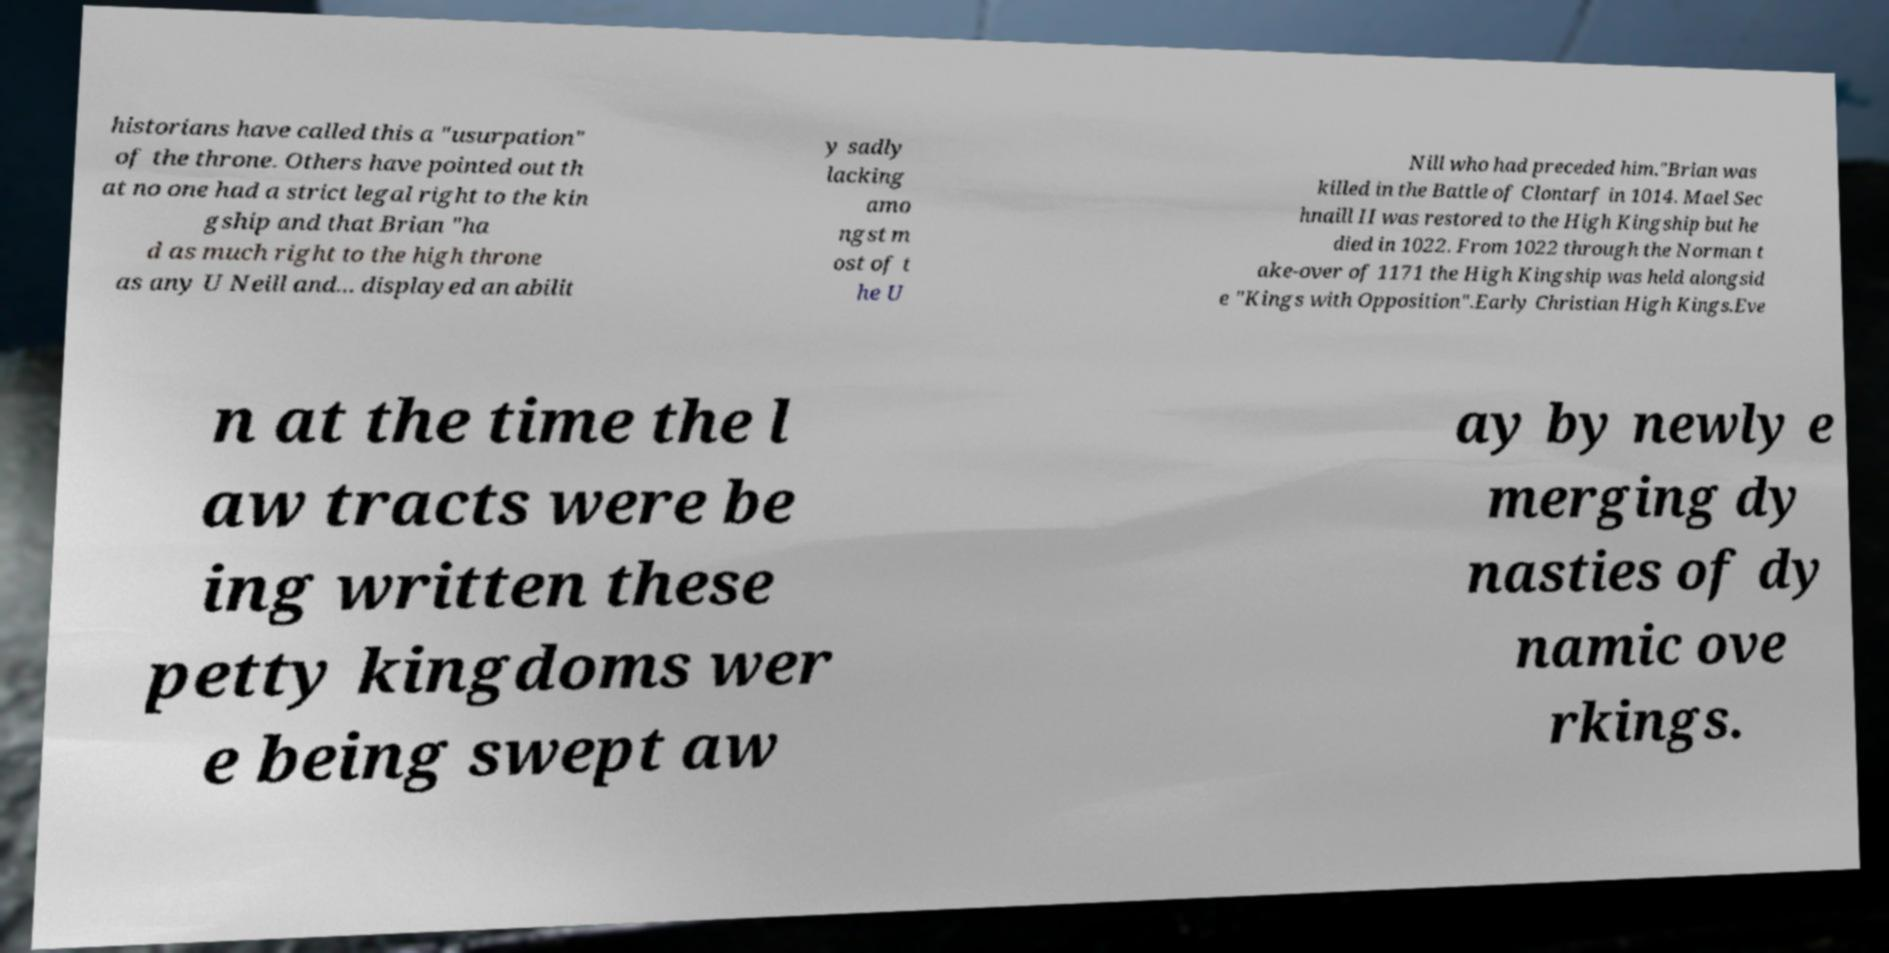Can you accurately transcribe the text from the provided image for me? historians have called this a "usurpation" of the throne. Others have pointed out th at no one had a strict legal right to the kin gship and that Brian "ha d as much right to the high throne as any U Neill and... displayed an abilit y sadly lacking amo ngst m ost of t he U Nill who had preceded him."Brian was killed in the Battle of Clontarf in 1014. Mael Sec hnaill II was restored to the High Kingship but he died in 1022. From 1022 through the Norman t ake-over of 1171 the High Kingship was held alongsid e "Kings with Opposition".Early Christian High Kings.Eve n at the time the l aw tracts were be ing written these petty kingdoms wer e being swept aw ay by newly e merging dy nasties of dy namic ove rkings. 